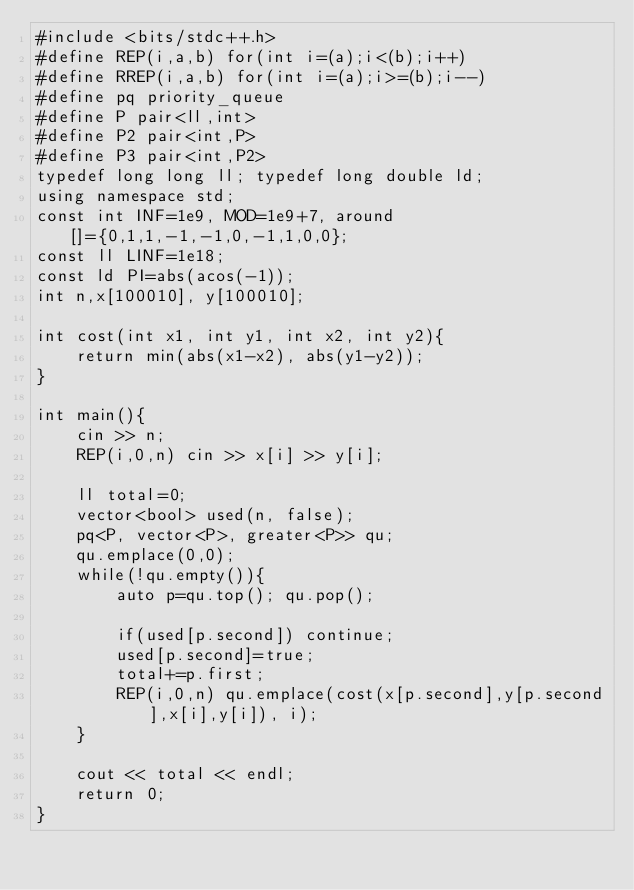Convert code to text. <code><loc_0><loc_0><loc_500><loc_500><_C++_>#include <bits/stdc++.h>
#define REP(i,a,b) for(int i=(a);i<(b);i++)
#define RREP(i,a,b) for(int i=(a);i>=(b);i--)
#define pq priority_queue
#define P pair<ll,int>
#define P2 pair<int,P>
#define P3 pair<int,P2>
typedef long long ll; typedef long double ld;
using namespace std;
const int INF=1e9, MOD=1e9+7, around[]={0,1,1,-1,-1,0,-1,1,0,0};
const ll LINF=1e18;
const ld PI=abs(acos(-1));
int n,x[100010], y[100010];

int cost(int x1, int y1, int x2, int y2){
	return min(abs(x1-x2), abs(y1-y2));
}

int main(){
	cin >> n;
	REP(i,0,n) cin >> x[i] >> y[i];
	
	ll total=0;
	vector<bool> used(n, false);
	pq<P, vector<P>, greater<P>> qu;
	qu.emplace(0,0);
	while(!qu.empty()){
		auto p=qu.top(); qu.pop();
		
		if(used[p.second]) continue;
		used[p.second]=true;
		total+=p.first;
		REP(i,0,n) qu.emplace(cost(x[p.second],y[p.second],x[i],y[i]), i);
	}
	
	cout << total << endl;
	return 0;
}

</code> 